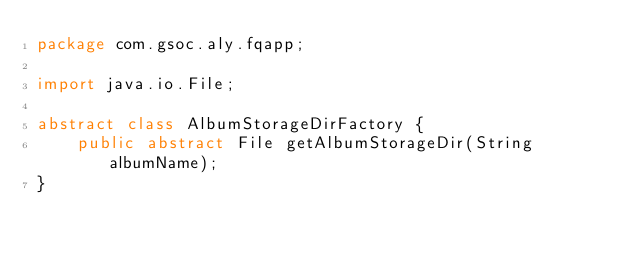<code> <loc_0><loc_0><loc_500><loc_500><_Java_>package com.gsoc.aly.fqapp;

import java.io.File;

abstract class AlbumStorageDirFactory {
	public abstract File getAlbumStorageDir(String albumName);
}
</code> 